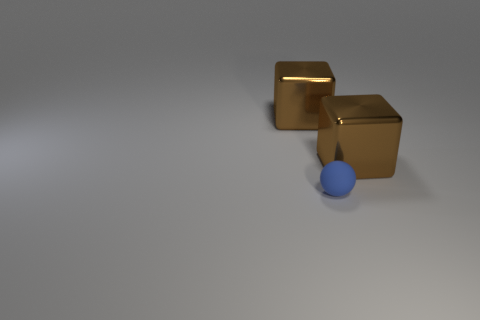Add 3 tiny green balls. How many objects exist? 6 Subtract all tiny matte spheres. Subtract all big shiny objects. How many objects are left? 0 Add 3 large cubes. How many large cubes are left? 5 Add 3 large cubes. How many large cubes exist? 5 Subtract 0 purple blocks. How many objects are left? 3 Subtract all cubes. How many objects are left? 1 Subtract all cyan cubes. Subtract all blue cylinders. How many cubes are left? 2 